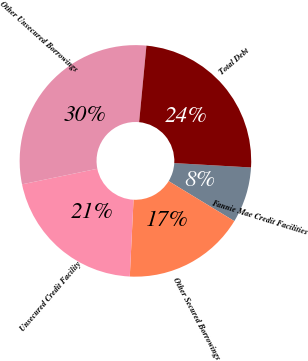<chart> <loc_0><loc_0><loc_500><loc_500><pie_chart><fcel>Fannie Mae Credit Facilities<fcel>Other Secured Borrowings<fcel>Unsecured Credit Facility<fcel>Other Unsecured Borrowings<fcel>Total Debt<nl><fcel>7.8%<fcel>17.07%<fcel>20.98%<fcel>29.76%<fcel>24.39%<nl></chart> 